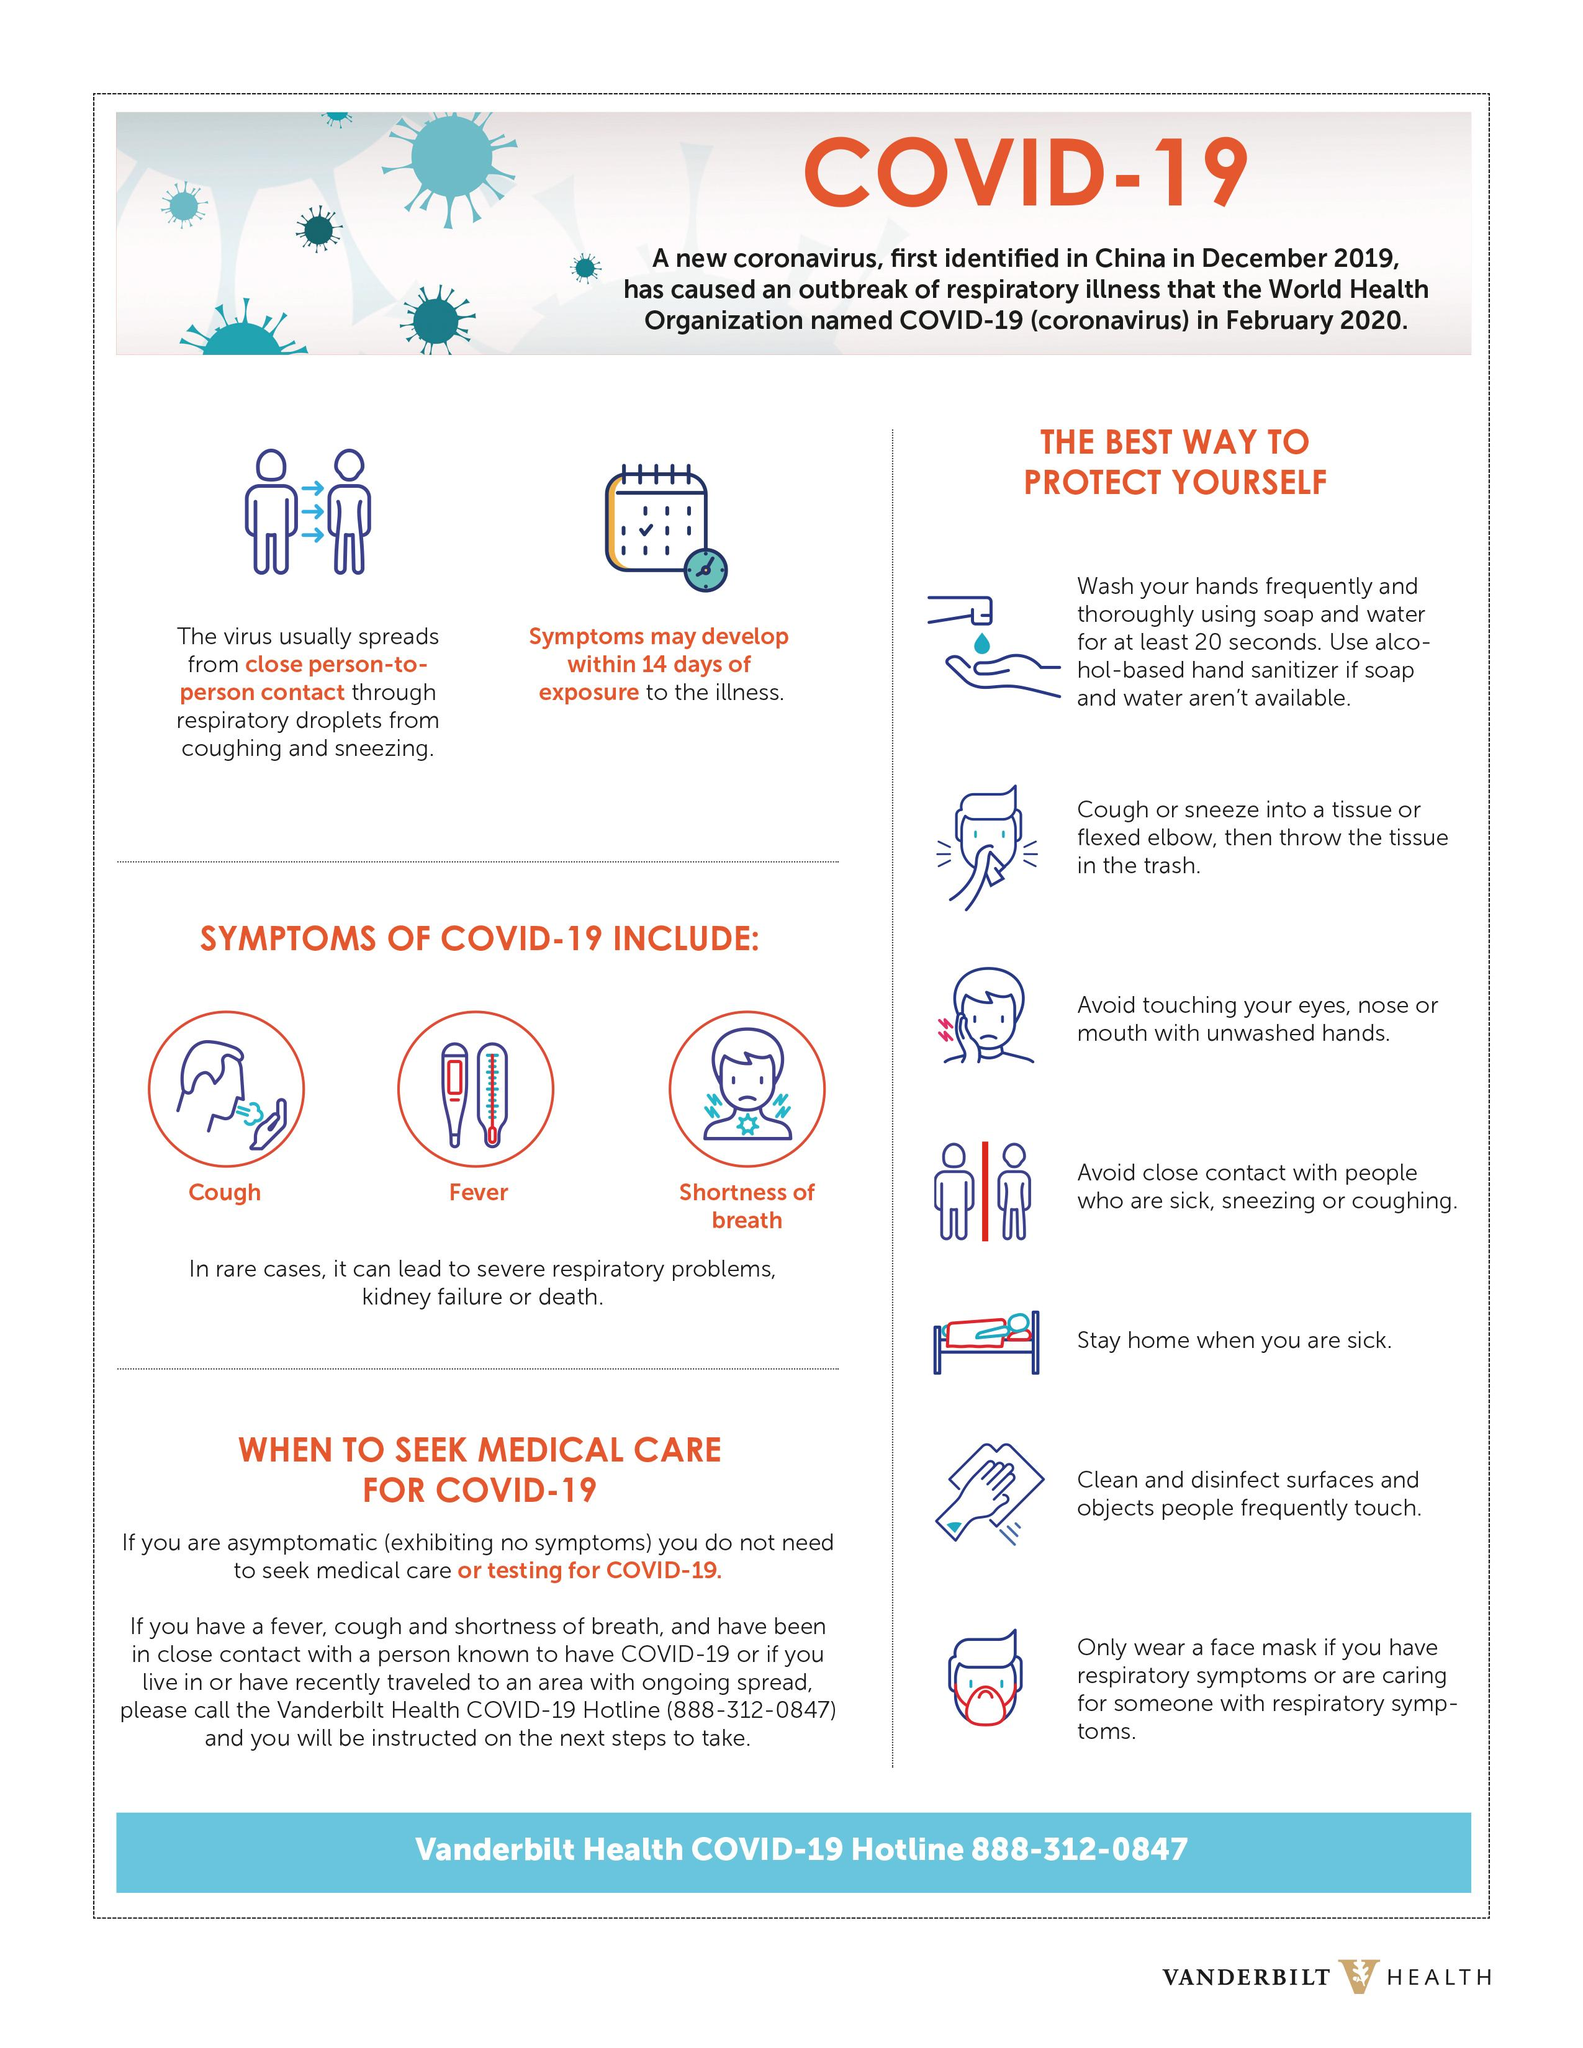Give some essential details in this illustration. The symptoms of COVID-19 other than fever include coughing and shortness of breath. There are 7 points under the heading "The best way to protect yourself. 